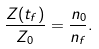Convert formula to latex. <formula><loc_0><loc_0><loc_500><loc_500>\frac { Z ( t _ { f } ) } { Z _ { 0 } } = \frac { n _ { 0 } } { n _ { f } } .</formula> 